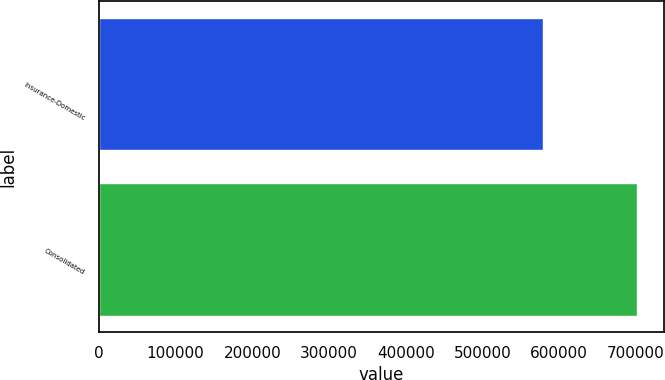Convert chart. <chart><loc_0><loc_0><loc_500><loc_500><bar_chart><fcel>Insurance-Domestic<fcel>Consolidated<nl><fcel>578500<fcel>701928<nl></chart> 